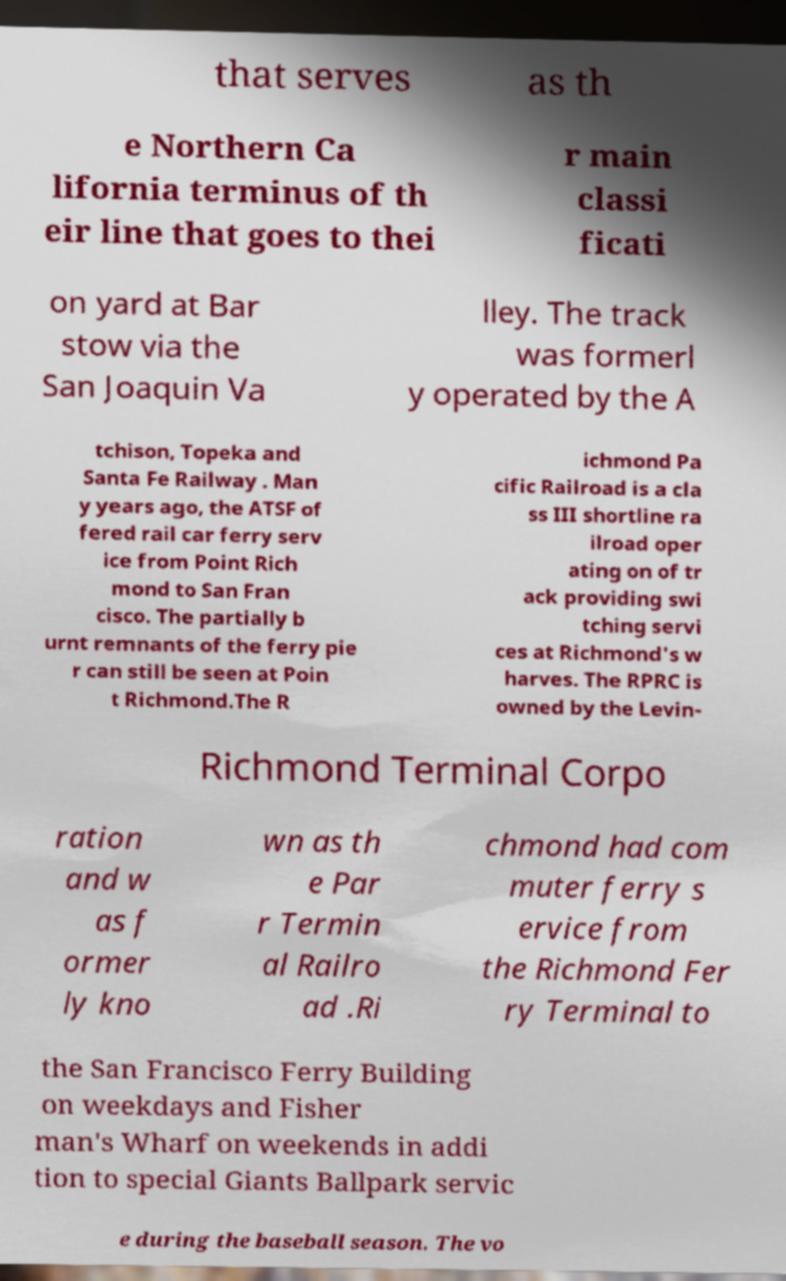Can you accurately transcribe the text from the provided image for me? that serves as th e Northern Ca lifornia terminus of th eir line that goes to thei r main classi ficati on yard at Bar stow via the San Joaquin Va lley. The track was formerl y operated by the A tchison, Topeka and Santa Fe Railway . Man y years ago, the ATSF of fered rail car ferry serv ice from Point Rich mond to San Fran cisco. The partially b urnt remnants of the ferry pie r can still be seen at Poin t Richmond.The R ichmond Pa cific Railroad is a cla ss III shortline ra ilroad oper ating on of tr ack providing swi tching servi ces at Richmond's w harves. The RPRC is owned by the Levin- Richmond Terminal Corpo ration and w as f ormer ly kno wn as th e Par r Termin al Railro ad .Ri chmond had com muter ferry s ervice from the Richmond Fer ry Terminal to the San Francisco Ferry Building on weekdays and Fisher man's Wharf on weekends in addi tion to special Giants Ballpark servic e during the baseball season. The vo 